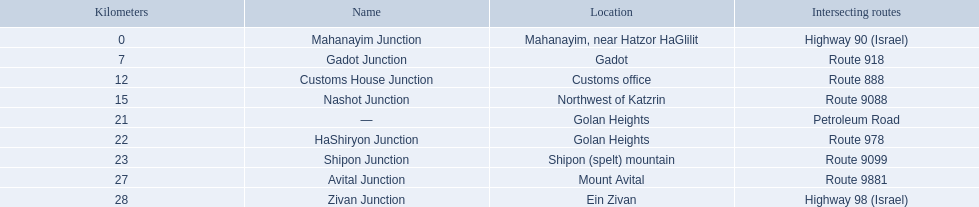Which junctions are located on numbered routes, and not highways or other types? Gadot Junction, Customs House Junction, Nashot Junction, HaShiryon Junction, Shipon Junction, Avital Junction. Of these junctions, which ones are located on routes with four digits (ex. route 9999)? Nashot Junction, Shipon Junction, Avital Junction. Of the remaining routes, which is located on shipon (spelt) mountain? Shipon Junction. 